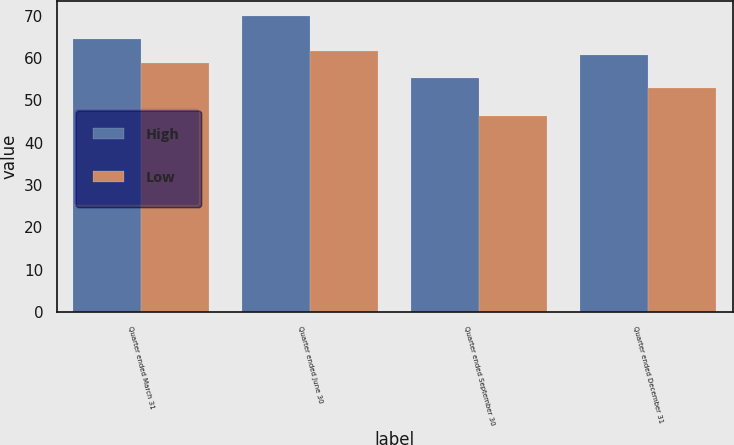Convert chart to OTSL. <chart><loc_0><loc_0><loc_500><loc_500><stacked_bar_chart><ecel><fcel>Quarter ended March 31<fcel>Quarter ended June 30<fcel>Quarter ended September 30<fcel>Quarter ended December 31<nl><fcel>High<fcel>64.38<fcel>69.91<fcel>55.21<fcel>60.7<nl><fcel>Low<fcel>58.81<fcel>61.62<fcel>46.35<fcel>52.86<nl></chart> 